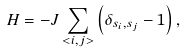Convert formula to latex. <formula><loc_0><loc_0><loc_500><loc_500>H = - J \sum _ { < i , j > } \left ( \delta _ { s _ { i } , s _ { j } } - 1 \right ) ,</formula> 